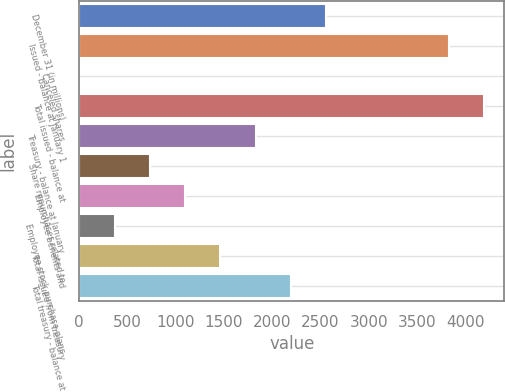Convert chart. <chart><loc_0><loc_0><loc_500><loc_500><bar_chart><fcel>December 31 (in millions)<fcel>Issued - balance at January 1<fcel>Canceled shares<fcel>Total issued - balance at<fcel>Treasury - balance at January<fcel>Share repurchases related to<fcel>Employee benefits and<fcel>Employee stock purchase plans<fcel>Total issued from treasury<fcel>Total treasury - balance at<nl><fcel>2560.55<fcel>3827.45<fcel>0.3<fcel>4193.2<fcel>1829.05<fcel>731.8<fcel>1097.55<fcel>366.05<fcel>1463.3<fcel>2194.8<nl></chart> 